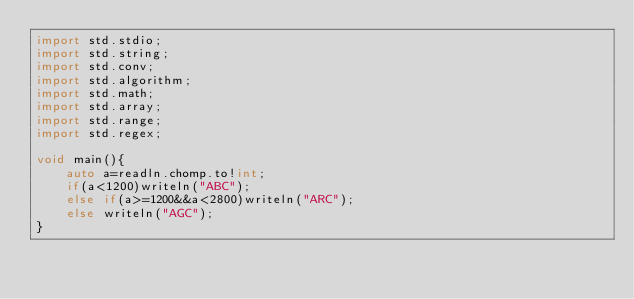Convert code to text. <code><loc_0><loc_0><loc_500><loc_500><_D_>import std.stdio;
import std.string;
import std.conv;
import std.algorithm;
import std.math;
import std.array;
import std.range;
import std.regex;

void main(){
	auto a=readln.chomp.to!int;
	if(a<1200)writeln("ABC");
	else if(a>=1200&&a<2800)writeln("ARC");
	else writeln("AGC");
}</code> 